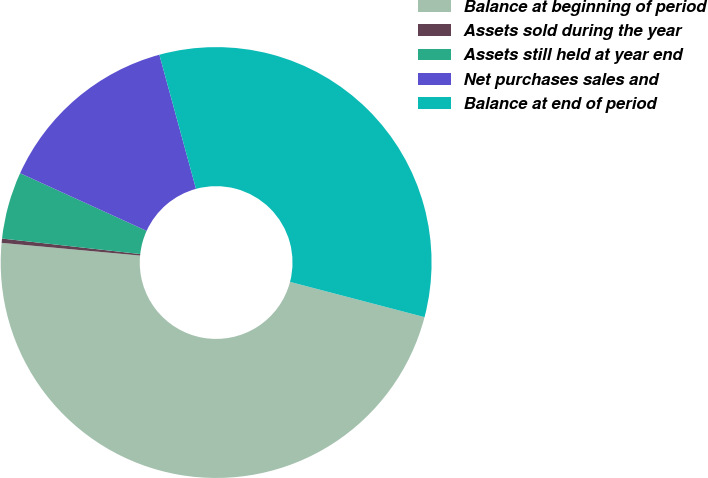Convert chart. <chart><loc_0><loc_0><loc_500><loc_500><pie_chart><fcel>Balance at beginning of period<fcel>Assets sold during the year<fcel>Assets still held at year end<fcel>Net purchases sales and<fcel>Balance at end of period<nl><fcel>47.38%<fcel>0.32%<fcel>5.03%<fcel>13.95%<fcel>33.32%<nl></chart> 